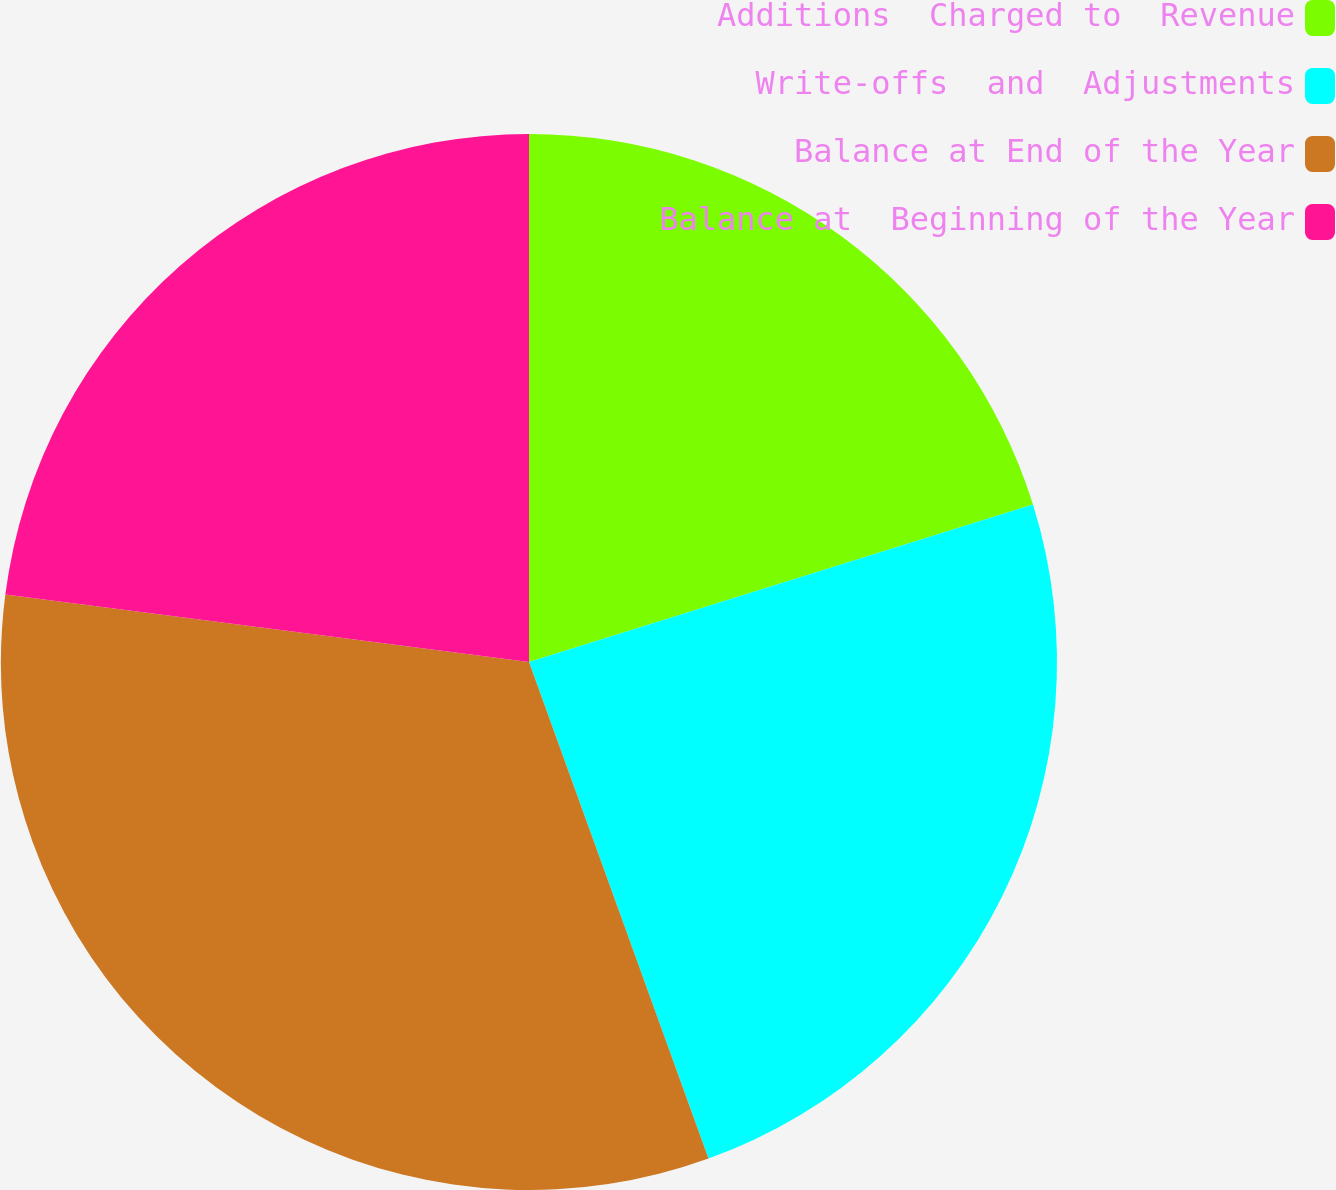Convert chart to OTSL. <chart><loc_0><loc_0><loc_500><loc_500><pie_chart><fcel>Additions  Charged to  Revenue<fcel>Write-offs  and  Adjustments<fcel>Balance at End of the Year<fcel>Balance at  Beginning of the Year<nl><fcel>20.18%<fcel>24.3%<fcel>32.56%<fcel>22.96%<nl></chart> 